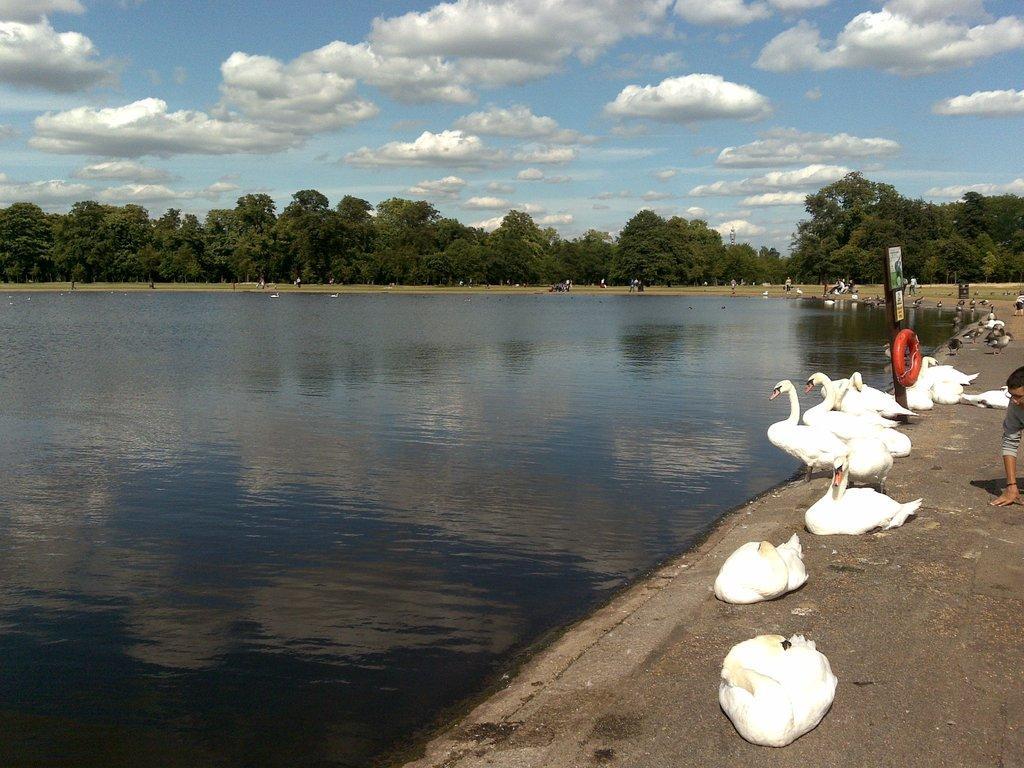Please provide a concise description of this image. In the center of the image there is a lake. On the right we can see swans and a board. There is a person. In the background there are trees and sky. 